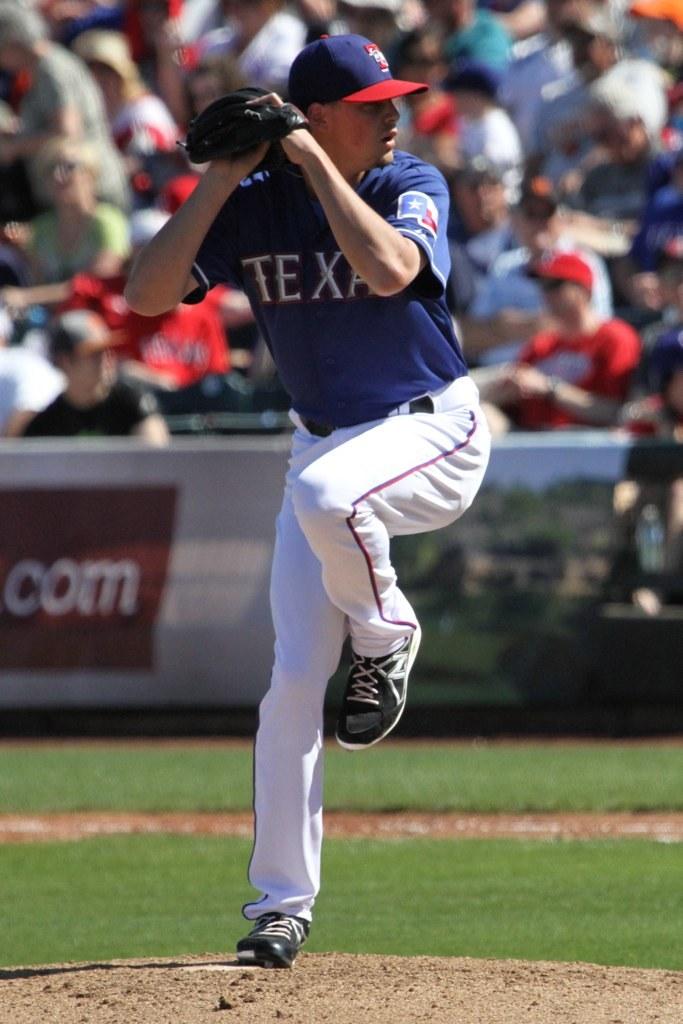Which state is shown on the jersey?
Keep it short and to the point. Texas. 